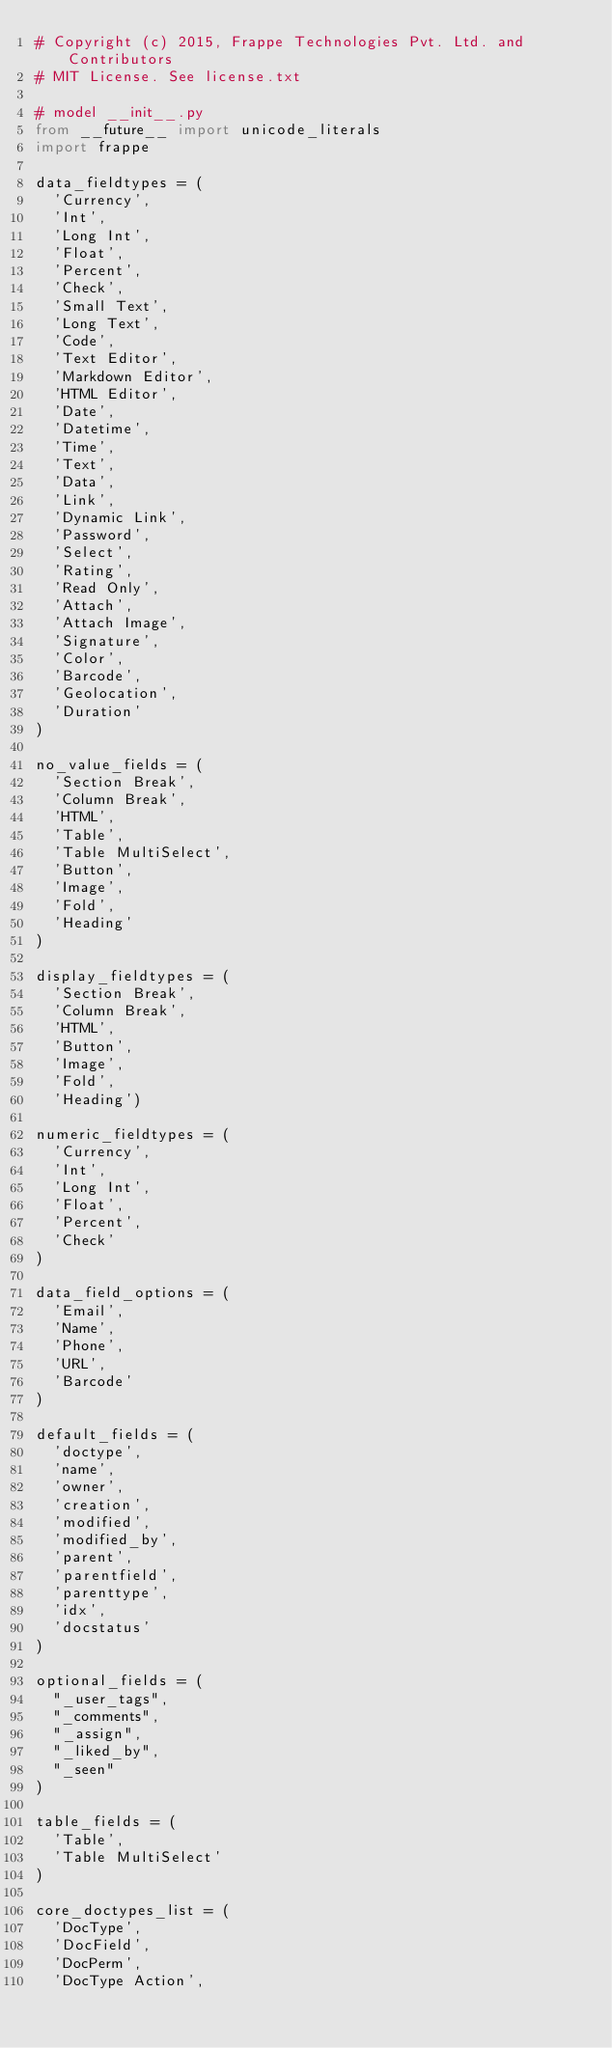<code> <loc_0><loc_0><loc_500><loc_500><_Python_># Copyright (c) 2015, Frappe Technologies Pvt. Ltd. and Contributors
# MIT License. See license.txt

# model __init__.py
from __future__ import unicode_literals
import frappe

data_fieldtypes = (
	'Currency',
	'Int',
	'Long Int',
	'Float',
	'Percent',
	'Check',
	'Small Text',
	'Long Text',
	'Code',
	'Text Editor',
	'Markdown Editor',
	'HTML Editor',
	'Date',
	'Datetime',
	'Time',
	'Text',
	'Data',
	'Link',
	'Dynamic Link',
	'Password',
	'Select',
	'Rating',
	'Read Only',
	'Attach',
	'Attach Image',
	'Signature',
	'Color',
	'Barcode',
	'Geolocation',
	'Duration'
)

no_value_fields = (
	'Section Break',
	'Column Break',
	'HTML',
	'Table',
	'Table MultiSelect',
	'Button',
	'Image',
	'Fold',
	'Heading'
)

display_fieldtypes = (
	'Section Break',
	'Column Break',
	'HTML',
	'Button',
	'Image',
	'Fold',
	'Heading')

numeric_fieldtypes = (
	'Currency',
	'Int',
	'Long Int',
	'Float',
	'Percent',
	'Check'
)

data_field_options = (
	'Email',
	'Name',
	'Phone',
	'URL',
	'Barcode'
)

default_fields = (
	'doctype',
	'name',
	'owner',
	'creation',
	'modified',
	'modified_by',
	'parent',
	'parentfield',
	'parenttype',
	'idx',
	'docstatus'
)

optional_fields = (
	"_user_tags",
	"_comments",
	"_assign",
	"_liked_by",
	"_seen"
)

table_fields = (
	'Table',
	'Table MultiSelect'
)

core_doctypes_list = (
	'DocType',
	'DocField',
	'DocPerm',
	'DocType Action',</code> 